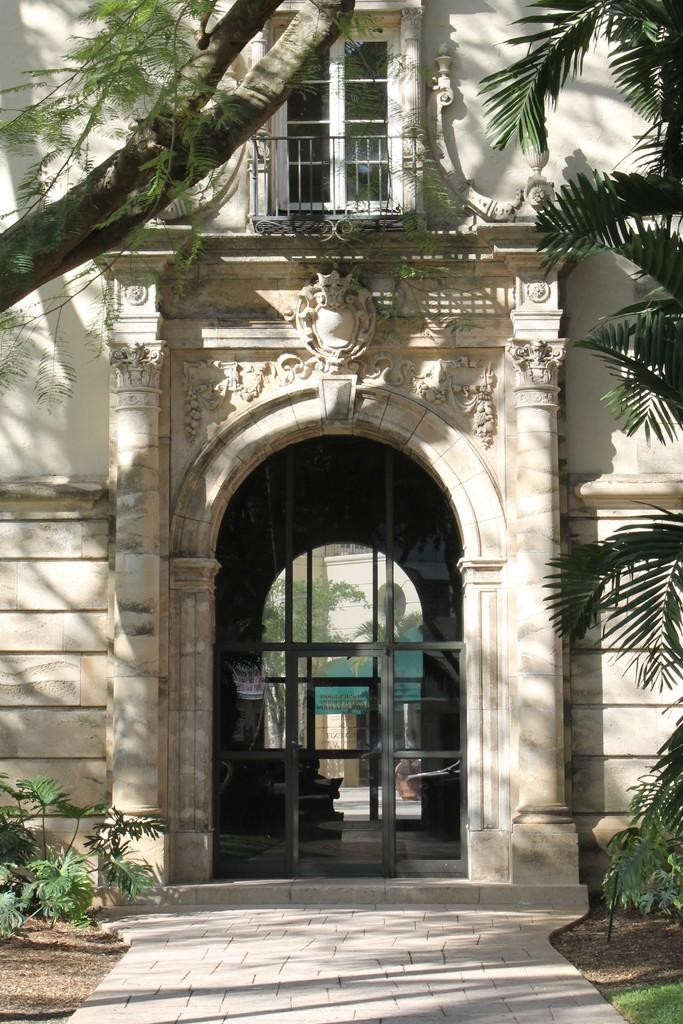What type of vegetation is in front of the building? There are plants in front of the building. What other natural element is in front of the building? There is a tree in front of the building. What architectural feature can be seen in the building? There is a window in the building. What entrance feature is present in the building? There is a glass door in the building. How many thumbs can be seen running in front of the building? There are no thumbs visible in the image, and they cannot run. Is there a bike parked in front of the building? The provided facts do not mention a bike, so it cannot be determined from the image. 